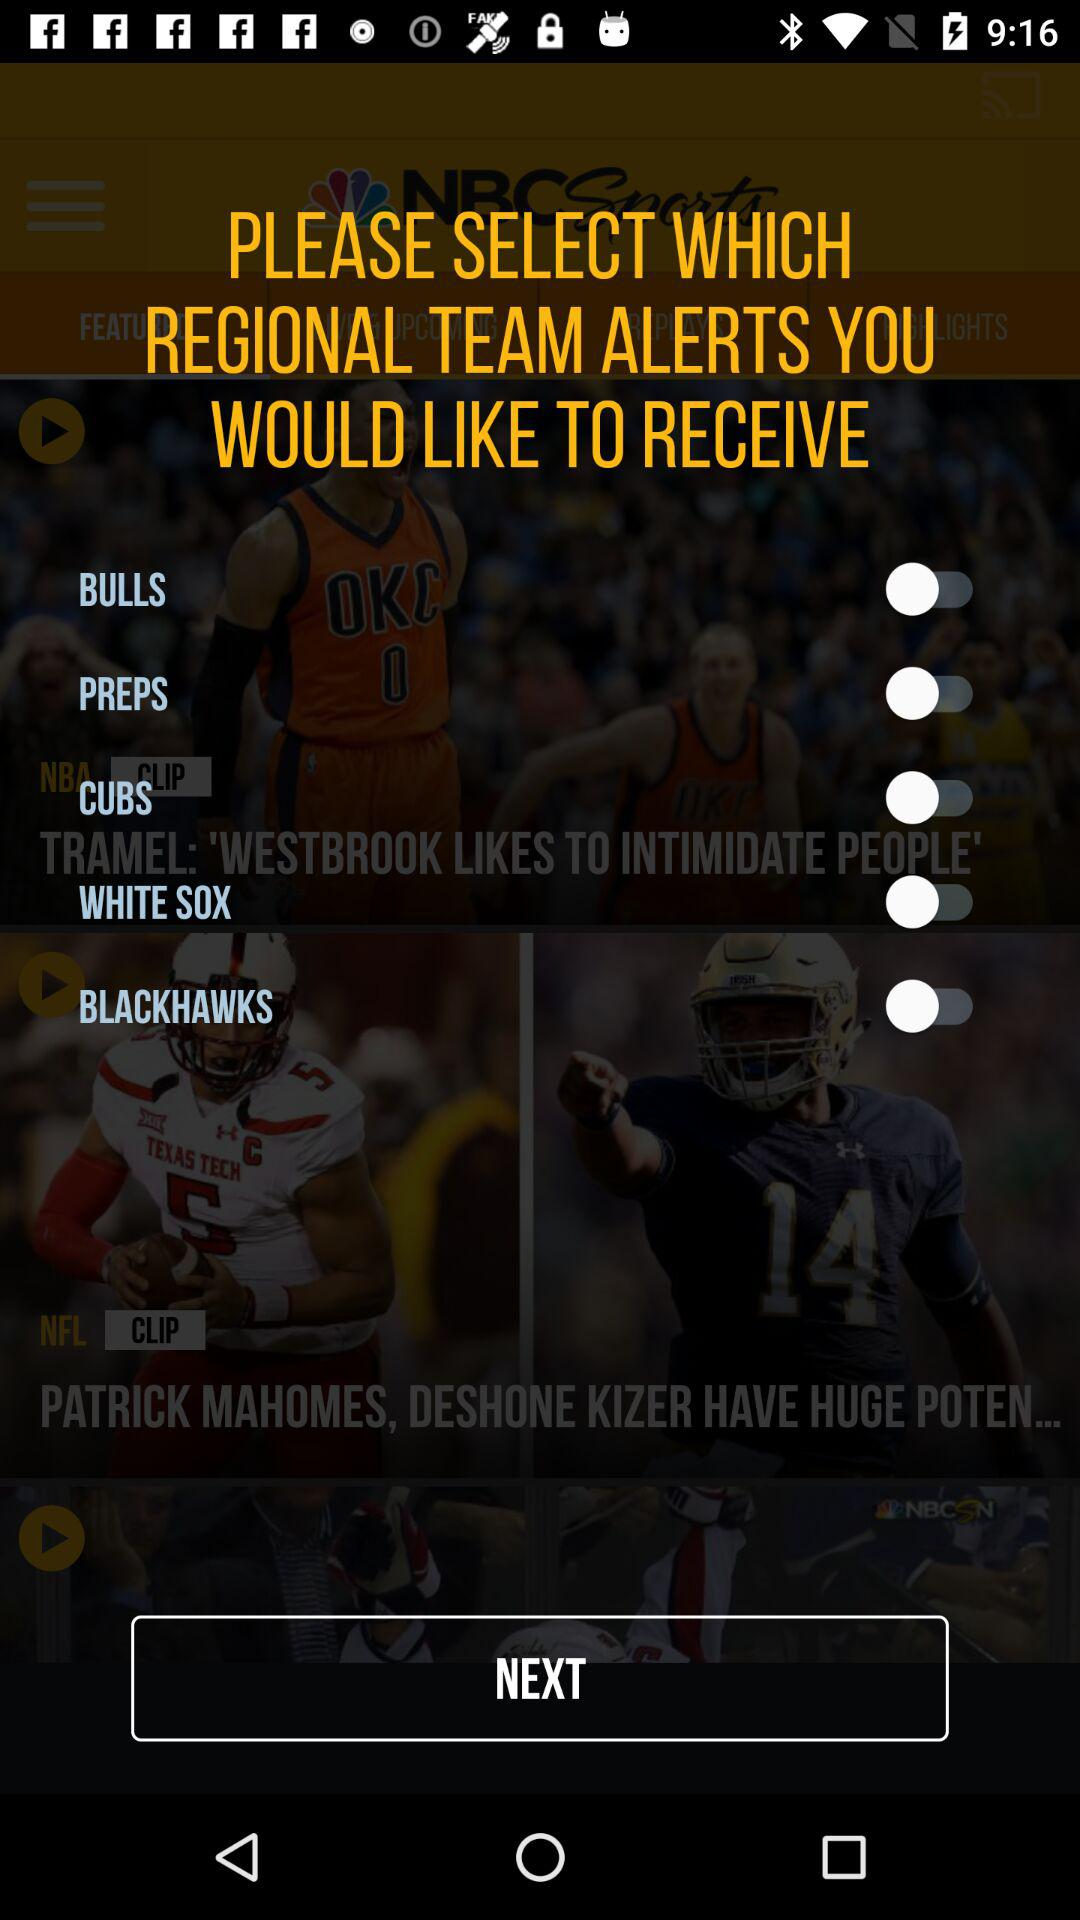What is the current status of "WHITE SOX"? The current status of "WHITE SOX" is "off". 